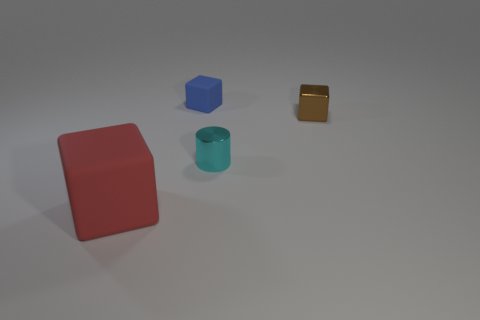Are there any other things that are the same size as the red matte object?
Offer a very short reply. No. Is there anything else that has the same shape as the small cyan metal thing?
Make the answer very short. No. Is there a tiny thing made of the same material as the tiny brown cube?
Give a very brief answer. Yes. What is the color of the tiny object that is behind the small shiny cube?
Provide a short and direct response. Blue. Are there the same number of blue cubes in front of the small blue rubber block and tiny cylinders behind the tiny cyan metallic thing?
Your answer should be compact. Yes. What is the material of the small cube that is right of the rubber block right of the large red cube?
Offer a terse response. Metal. What number of things are either tiny green cylinders or rubber cubes behind the cyan metal cylinder?
Give a very brief answer. 1. What size is the object that is the same material as the blue cube?
Provide a short and direct response. Large. Are there more shiny cylinders that are in front of the small brown thing than small gray matte cylinders?
Make the answer very short. Yes. There is a block that is both in front of the blue cube and left of the brown metallic thing; what is its size?
Make the answer very short. Large. 